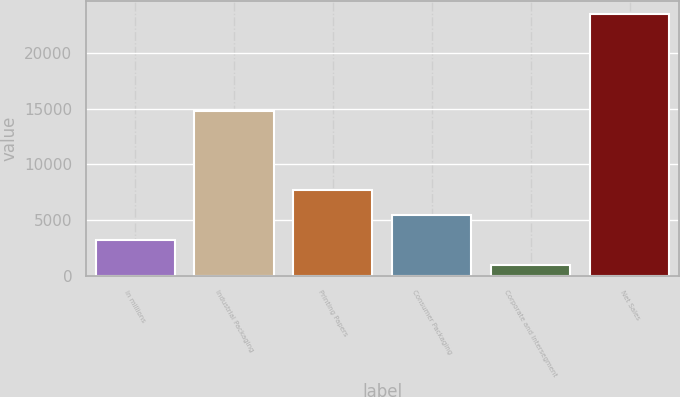Convert chart to OTSL. <chart><loc_0><loc_0><loc_500><loc_500><bar_chart><fcel>In millions<fcel>Industrial Packaging<fcel>Printing Papers<fcel>Consumer Packaging<fcel>Corporate and Intersegment<fcel>Net Sales<nl><fcel>3218.6<fcel>14810<fcel>7721.8<fcel>5470.2<fcel>967<fcel>23483<nl></chart> 